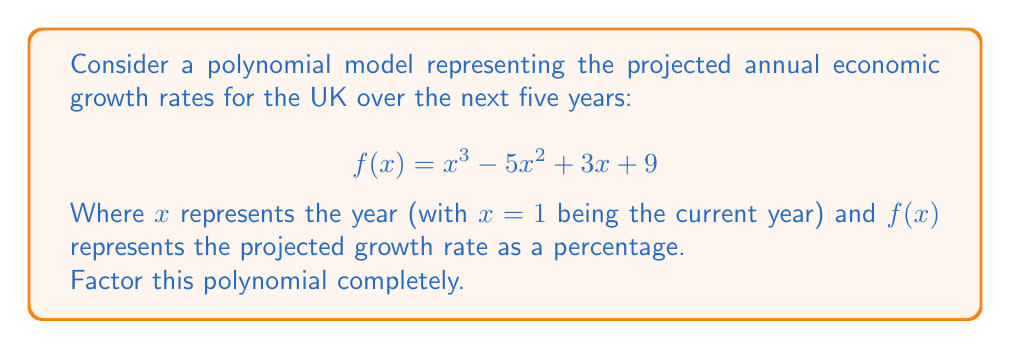Show me your answer to this math problem. To factor this polynomial, we'll follow these steps:

1) First, let's check if there are any rational roots using the rational root theorem. The possible rational roots are the factors of the constant term (9): ±1, ±3, ±9.

2) Testing these values, we find that $f(3) = 0$. So $(x - 3)$ is a factor.

3) We can use polynomial long division to divide $f(x)$ by $(x - 3)$:

   $x^3 - 5x^2 + 3x + 9 = (x - 3)(x^2 - 2x - 3) + 0$

4) Now we need to factor the quadratic term $x^2 - 2x - 3$. We can do this by finding two numbers that multiply to give -3 and add to give -2. These numbers are -3 and 1.

5) Therefore, $x^2 - 2x - 3 = (x - 3)(x + 1)$

6) Combining all of this, we get:

   $f(x) = (x - 3)(x^2 - 2x - 3) = (x - 3)(x - 3)(x + 1)$

This factorization shows that the growth rate will be zero (i.e., no growth) in the third year and will change from positive to negative (or vice versa) in the current year.
Answer: $f(x) = (x - 3)^2(x + 1)$ 